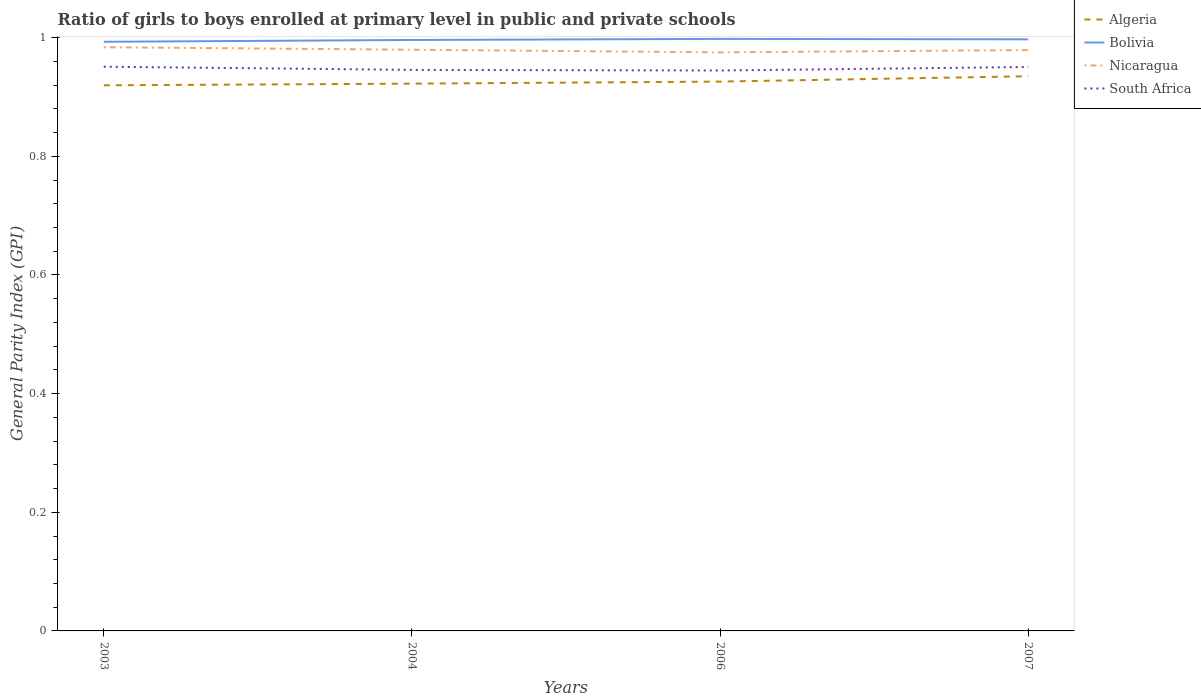Does the line corresponding to Algeria intersect with the line corresponding to Bolivia?
Ensure brevity in your answer.  No. Across all years, what is the maximum general parity index in Bolivia?
Provide a short and direct response. 0.99. What is the total general parity index in Algeria in the graph?
Make the answer very short. -0. What is the difference between the highest and the second highest general parity index in South Africa?
Your response must be concise. 0.01. Is the general parity index in Algeria strictly greater than the general parity index in Bolivia over the years?
Provide a succinct answer. Yes. How many years are there in the graph?
Provide a succinct answer. 4. Does the graph contain grids?
Provide a short and direct response. No. Where does the legend appear in the graph?
Offer a very short reply. Top right. What is the title of the graph?
Provide a succinct answer. Ratio of girls to boys enrolled at primary level in public and private schools. What is the label or title of the Y-axis?
Keep it short and to the point. General Parity Index (GPI). What is the General Parity Index (GPI) of Algeria in 2003?
Your answer should be very brief. 0.92. What is the General Parity Index (GPI) in Bolivia in 2003?
Make the answer very short. 0.99. What is the General Parity Index (GPI) in Nicaragua in 2003?
Ensure brevity in your answer.  0.98. What is the General Parity Index (GPI) in South Africa in 2003?
Your answer should be compact. 0.95. What is the General Parity Index (GPI) in Algeria in 2004?
Your response must be concise. 0.92. What is the General Parity Index (GPI) in Bolivia in 2004?
Offer a very short reply. 1. What is the General Parity Index (GPI) of Nicaragua in 2004?
Provide a succinct answer. 0.98. What is the General Parity Index (GPI) in South Africa in 2004?
Offer a terse response. 0.95. What is the General Parity Index (GPI) in Algeria in 2006?
Ensure brevity in your answer.  0.93. What is the General Parity Index (GPI) of Bolivia in 2006?
Make the answer very short. 1. What is the General Parity Index (GPI) in Nicaragua in 2006?
Provide a short and direct response. 0.98. What is the General Parity Index (GPI) in South Africa in 2006?
Offer a very short reply. 0.94. What is the General Parity Index (GPI) in Algeria in 2007?
Make the answer very short. 0.94. What is the General Parity Index (GPI) in Bolivia in 2007?
Offer a very short reply. 1. What is the General Parity Index (GPI) in Nicaragua in 2007?
Your response must be concise. 0.98. What is the General Parity Index (GPI) in South Africa in 2007?
Give a very brief answer. 0.95. Across all years, what is the maximum General Parity Index (GPI) of Algeria?
Your answer should be compact. 0.94. Across all years, what is the maximum General Parity Index (GPI) of Bolivia?
Your response must be concise. 1. Across all years, what is the maximum General Parity Index (GPI) of Nicaragua?
Your answer should be very brief. 0.98. Across all years, what is the maximum General Parity Index (GPI) in South Africa?
Keep it short and to the point. 0.95. Across all years, what is the minimum General Parity Index (GPI) of Algeria?
Provide a succinct answer. 0.92. Across all years, what is the minimum General Parity Index (GPI) in Bolivia?
Offer a very short reply. 0.99. Across all years, what is the minimum General Parity Index (GPI) in Nicaragua?
Your answer should be compact. 0.98. Across all years, what is the minimum General Parity Index (GPI) in South Africa?
Your response must be concise. 0.94. What is the total General Parity Index (GPI) in Algeria in the graph?
Offer a terse response. 3.7. What is the total General Parity Index (GPI) in Bolivia in the graph?
Make the answer very short. 3.98. What is the total General Parity Index (GPI) of Nicaragua in the graph?
Provide a succinct answer. 3.92. What is the total General Parity Index (GPI) in South Africa in the graph?
Offer a terse response. 3.79. What is the difference between the General Parity Index (GPI) in Algeria in 2003 and that in 2004?
Your response must be concise. -0. What is the difference between the General Parity Index (GPI) in Bolivia in 2003 and that in 2004?
Keep it short and to the point. -0. What is the difference between the General Parity Index (GPI) of Nicaragua in 2003 and that in 2004?
Make the answer very short. 0. What is the difference between the General Parity Index (GPI) in South Africa in 2003 and that in 2004?
Offer a very short reply. 0.01. What is the difference between the General Parity Index (GPI) in Algeria in 2003 and that in 2006?
Give a very brief answer. -0.01. What is the difference between the General Parity Index (GPI) of Bolivia in 2003 and that in 2006?
Give a very brief answer. -0. What is the difference between the General Parity Index (GPI) in Nicaragua in 2003 and that in 2006?
Offer a terse response. 0.01. What is the difference between the General Parity Index (GPI) of South Africa in 2003 and that in 2006?
Provide a short and direct response. 0.01. What is the difference between the General Parity Index (GPI) of Algeria in 2003 and that in 2007?
Make the answer very short. -0.02. What is the difference between the General Parity Index (GPI) in Bolivia in 2003 and that in 2007?
Provide a short and direct response. -0. What is the difference between the General Parity Index (GPI) of Nicaragua in 2003 and that in 2007?
Your answer should be very brief. 0. What is the difference between the General Parity Index (GPI) in South Africa in 2003 and that in 2007?
Your answer should be very brief. 0. What is the difference between the General Parity Index (GPI) of Algeria in 2004 and that in 2006?
Ensure brevity in your answer.  -0. What is the difference between the General Parity Index (GPI) of Bolivia in 2004 and that in 2006?
Your response must be concise. -0. What is the difference between the General Parity Index (GPI) in Nicaragua in 2004 and that in 2006?
Your response must be concise. 0. What is the difference between the General Parity Index (GPI) in South Africa in 2004 and that in 2006?
Make the answer very short. 0. What is the difference between the General Parity Index (GPI) of Algeria in 2004 and that in 2007?
Ensure brevity in your answer.  -0.01. What is the difference between the General Parity Index (GPI) of Bolivia in 2004 and that in 2007?
Keep it short and to the point. -0. What is the difference between the General Parity Index (GPI) of Nicaragua in 2004 and that in 2007?
Your response must be concise. 0. What is the difference between the General Parity Index (GPI) of South Africa in 2004 and that in 2007?
Ensure brevity in your answer.  -0. What is the difference between the General Parity Index (GPI) of Algeria in 2006 and that in 2007?
Keep it short and to the point. -0.01. What is the difference between the General Parity Index (GPI) in Bolivia in 2006 and that in 2007?
Offer a very short reply. 0. What is the difference between the General Parity Index (GPI) in Nicaragua in 2006 and that in 2007?
Make the answer very short. -0. What is the difference between the General Parity Index (GPI) of South Africa in 2006 and that in 2007?
Offer a terse response. -0.01. What is the difference between the General Parity Index (GPI) in Algeria in 2003 and the General Parity Index (GPI) in Bolivia in 2004?
Keep it short and to the point. -0.08. What is the difference between the General Parity Index (GPI) of Algeria in 2003 and the General Parity Index (GPI) of Nicaragua in 2004?
Give a very brief answer. -0.06. What is the difference between the General Parity Index (GPI) in Algeria in 2003 and the General Parity Index (GPI) in South Africa in 2004?
Your response must be concise. -0.03. What is the difference between the General Parity Index (GPI) in Bolivia in 2003 and the General Parity Index (GPI) in Nicaragua in 2004?
Provide a succinct answer. 0.01. What is the difference between the General Parity Index (GPI) in Bolivia in 2003 and the General Parity Index (GPI) in South Africa in 2004?
Your answer should be very brief. 0.05. What is the difference between the General Parity Index (GPI) of Nicaragua in 2003 and the General Parity Index (GPI) of South Africa in 2004?
Make the answer very short. 0.04. What is the difference between the General Parity Index (GPI) of Algeria in 2003 and the General Parity Index (GPI) of Bolivia in 2006?
Provide a succinct answer. -0.08. What is the difference between the General Parity Index (GPI) of Algeria in 2003 and the General Parity Index (GPI) of Nicaragua in 2006?
Offer a very short reply. -0.06. What is the difference between the General Parity Index (GPI) in Algeria in 2003 and the General Parity Index (GPI) in South Africa in 2006?
Keep it short and to the point. -0.03. What is the difference between the General Parity Index (GPI) in Bolivia in 2003 and the General Parity Index (GPI) in Nicaragua in 2006?
Give a very brief answer. 0.02. What is the difference between the General Parity Index (GPI) in Bolivia in 2003 and the General Parity Index (GPI) in South Africa in 2006?
Make the answer very short. 0.05. What is the difference between the General Parity Index (GPI) in Nicaragua in 2003 and the General Parity Index (GPI) in South Africa in 2006?
Offer a very short reply. 0.04. What is the difference between the General Parity Index (GPI) in Algeria in 2003 and the General Parity Index (GPI) in Bolivia in 2007?
Your response must be concise. -0.08. What is the difference between the General Parity Index (GPI) in Algeria in 2003 and the General Parity Index (GPI) in Nicaragua in 2007?
Provide a succinct answer. -0.06. What is the difference between the General Parity Index (GPI) in Algeria in 2003 and the General Parity Index (GPI) in South Africa in 2007?
Give a very brief answer. -0.03. What is the difference between the General Parity Index (GPI) in Bolivia in 2003 and the General Parity Index (GPI) in Nicaragua in 2007?
Ensure brevity in your answer.  0.01. What is the difference between the General Parity Index (GPI) in Bolivia in 2003 and the General Parity Index (GPI) in South Africa in 2007?
Offer a very short reply. 0.04. What is the difference between the General Parity Index (GPI) in Algeria in 2004 and the General Parity Index (GPI) in Bolivia in 2006?
Offer a terse response. -0.08. What is the difference between the General Parity Index (GPI) of Algeria in 2004 and the General Parity Index (GPI) of Nicaragua in 2006?
Offer a terse response. -0.05. What is the difference between the General Parity Index (GPI) of Algeria in 2004 and the General Parity Index (GPI) of South Africa in 2006?
Your answer should be compact. -0.02. What is the difference between the General Parity Index (GPI) in Bolivia in 2004 and the General Parity Index (GPI) in Nicaragua in 2006?
Make the answer very short. 0.02. What is the difference between the General Parity Index (GPI) in Bolivia in 2004 and the General Parity Index (GPI) in South Africa in 2006?
Make the answer very short. 0.05. What is the difference between the General Parity Index (GPI) in Nicaragua in 2004 and the General Parity Index (GPI) in South Africa in 2006?
Provide a succinct answer. 0.04. What is the difference between the General Parity Index (GPI) in Algeria in 2004 and the General Parity Index (GPI) in Bolivia in 2007?
Ensure brevity in your answer.  -0.07. What is the difference between the General Parity Index (GPI) of Algeria in 2004 and the General Parity Index (GPI) of Nicaragua in 2007?
Give a very brief answer. -0.06. What is the difference between the General Parity Index (GPI) of Algeria in 2004 and the General Parity Index (GPI) of South Africa in 2007?
Your answer should be very brief. -0.03. What is the difference between the General Parity Index (GPI) in Bolivia in 2004 and the General Parity Index (GPI) in Nicaragua in 2007?
Give a very brief answer. 0.02. What is the difference between the General Parity Index (GPI) of Bolivia in 2004 and the General Parity Index (GPI) of South Africa in 2007?
Your answer should be very brief. 0.05. What is the difference between the General Parity Index (GPI) in Nicaragua in 2004 and the General Parity Index (GPI) in South Africa in 2007?
Provide a short and direct response. 0.03. What is the difference between the General Parity Index (GPI) in Algeria in 2006 and the General Parity Index (GPI) in Bolivia in 2007?
Make the answer very short. -0.07. What is the difference between the General Parity Index (GPI) in Algeria in 2006 and the General Parity Index (GPI) in Nicaragua in 2007?
Your answer should be very brief. -0.05. What is the difference between the General Parity Index (GPI) of Algeria in 2006 and the General Parity Index (GPI) of South Africa in 2007?
Your answer should be very brief. -0.02. What is the difference between the General Parity Index (GPI) in Bolivia in 2006 and the General Parity Index (GPI) in Nicaragua in 2007?
Your response must be concise. 0.02. What is the difference between the General Parity Index (GPI) in Bolivia in 2006 and the General Parity Index (GPI) in South Africa in 2007?
Your answer should be compact. 0.05. What is the difference between the General Parity Index (GPI) in Nicaragua in 2006 and the General Parity Index (GPI) in South Africa in 2007?
Your answer should be compact. 0.02. What is the average General Parity Index (GPI) of Algeria per year?
Ensure brevity in your answer.  0.93. What is the average General Parity Index (GPI) of Bolivia per year?
Your answer should be compact. 1. What is the average General Parity Index (GPI) of Nicaragua per year?
Your answer should be compact. 0.98. What is the average General Parity Index (GPI) of South Africa per year?
Provide a succinct answer. 0.95. In the year 2003, what is the difference between the General Parity Index (GPI) of Algeria and General Parity Index (GPI) of Bolivia?
Provide a short and direct response. -0.07. In the year 2003, what is the difference between the General Parity Index (GPI) of Algeria and General Parity Index (GPI) of Nicaragua?
Your answer should be compact. -0.06. In the year 2003, what is the difference between the General Parity Index (GPI) of Algeria and General Parity Index (GPI) of South Africa?
Provide a succinct answer. -0.03. In the year 2003, what is the difference between the General Parity Index (GPI) of Bolivia and General Parity Index (GPI) of Nicaragua?
Your answer should be very brief. 0.01. In the year 2003, what is the difference between the General Parity Index (GPI) in Bolivia and General Parity Index (GPI) in South Africa?
Your response must be concise. 0.04. In the year 2003, what is the difference between the General Parity Index (GPI) in Nicaragua and General Parity Index (GPI) in South Africa?
Offer a terse response. 0.03. In the year 2004, what is the difference between the General Parity Index (GPI) of Algeria and General Parity Index (GPI) of Bolivia?
Give a very brief answer. -0.07. In the year 2004, what is the difference between the General Parity Index (GPI) of Algeria and General Parity Index (GPI) of Nicaragua?
Your answer should be compact. -0.06. In the year 2004, what is the difference between the General Parity Index (GPI) of Algeria and General Parity Index (GPI) of South Africa?
Give a very brief answer. -0.02. In the year 2004, what is the difference between the General Parity Index (GPI) of Bolivia and General Parity Index (GPI) of Nicaragua?
Your answer should be compact. 0.02. In the year 2004, what is the difference between the General Parity Index (GPI) in Bolivia and General Parity Index (GPI) in South Africa?
Your response must be concise. 0.05. In the year 2004, what is the difference between the General Parity Index (GPI) of Nicaragua and General Parity Index (GPI) of South Africa?
Your answer should be compact. 0.03. In the year 2006, what is the difference between the General Parity Index (GPI) in Algeria and General Parity Index (GPI) in Bolivia?
Offer a very short reply. -0.07. In the year 2006, what is the difference between the General Parity Index (GPI) of Algeria and General Parity Index (GPI) of Nicaragua?
Offer a terse response. -0.05. In the year 2006, what is the difference between the General Parity Index (GPI) in Algeria and General Parity Index (GPI) in South Africa?
Offer a terse response. -0.02. In the year 2006, what is the difference between the General Parity Index (GPI) of Bolivia and General Parity Index (GPI) of Nicaragua?
Your answer should be compact. 0.02. In the year 2006, what is the difference between the General Parity Index (GPI) of Bolivia and General Parity Index (GPI) of South Africa?
Give a very brief answer. 0.05. In the year 2006, what is the difference between the General Parity Index (GPI) of Nicaragua and General Parity Index (GPI) of South Africa?
Give a very brief answer. 0.03. In the year 2007, what is the difference between the General Parity Index (GPI) of Algeria and General Parity Index (GPI) of Bolivia?
Give a very brief answer. -0.06. In the year 2007, what is the difference between the General Parity Index (GPI) in Algeria and General Parity Index (GPI) in Nicaragua?
Make the answer very short. -0.04. In the year 2007, what is the difference between the General Parity Index (GPI) in Algeria and General Parity Index (GPI) in South Africa?
Provide a succinct answer. -0.02. In the year 2007, what is the difference between the General Parity Index (GPI) in Bolivia and General Parity Index (GPI) in Nicaragua?
Your answer should be compact. 0.02. In the year 2007, what is the difference between the General Parity Index (GPI) of Bolivia and General Parity Index (GPI) of South Africa?
Offer a very short reply. 0.05. In the year 2007, what is the difference between the General Parity Index (GPI) of Nicaragua and General Parity Index (GPI) of South Africa?
Your answer should be very brief. 0.03. What is the ratio of the General Parity Index (GPI) of Bolivia in 2003 to that in 2004?
Offer a very short reply. 1. What is the ratio of the General Parity Index (GPI) of South Africa in 2003 to that in 2004?
Your response must be concise. 1.01. What is the ratio of the General Parity Index (GPI) of Algeria in 2003 to that in 2006?
Ensure brevity in your answer.  0.99. What is the ratio of the General Parity Index (GPI) in Bolivia in 2003 to that in 2006?
Your answer should be compact. 1. What is the ratio of the General Parity Index (GPI) of Nicaragua in 2003 to that in 2006?
Your answer should be compact. 1.01. What is the ratio of the General Parity Index (GPI) in South Africa in 2003 to that in 2006?
Offer a terse response. 1.01. What is the ratio of the General Parity Index (GPI) of Algeria in 2003 to that in 2007?
Keep it short and to the point. 0.98. What is the ratio of the General Parity Index (GPI) of Bolivia in 2003 to that in 2007?
Your answer should be compact. 1. What is the ratio of the General Parity Index (GPI) in Bolivia in 2004 to that in 2006?
Keep it short and to the point. 1. What is the ratio of the General Parity Index (GPI) of Nicaragua in 2004 to that in 2006?
Give a very brief answer. 1. What is the ratio of the General Parity Index (GPI) of Algeria in 2004 to that in 2007?
Provide a short and direct response. 0.99. What is the ratio of the General Parity Index (GPI) in Nicaragua in 2004 to that in 2007?
Your answer should be compact. 1. What is the ratio of the General Parity Index (GPI) in South Africa in 2004 to that in 2007?
Keep it short and to the point. 0.99. What is the ratio of the General Parity Index (GPI) of Bolivia in 2006 to that in 2007?
Provide a succinct answer. 1. What is the ratio of the General Parity Index (GPI) of South Africa in 2006 to that in 2007?
Give a very brief answer. 0.99. What is the difference between the highest and the second highest General Parity Index (GPI) in Algeria?
Offer a terse response. 0.01. What is the difference between the highest and the second highest General Parity Index (GPI) of Bolivia?
Give a very brief answer. 0. What is the difference between the highest and the second highest General Parity Index (GPI) of Nicaragua?
Your answer should be compact. 0. What is the difference between the highest and the lowest General Parity Index (GPI) in Algeria?
Ensure brevity in your answer.  0.02. What is the difference between the highest and the lowest General Parity Index (GPI) of Bolivia?
Give a very brief answer. 0. What is the difference between the highest and the lowest General Parity Index (GPI) of Nicaragua?
Offer a terse response. 0.01. What is the difference between the highest and the lowest General Parity Index (GPI) of South Africa?
Your answer should be very brief. 0.01. 